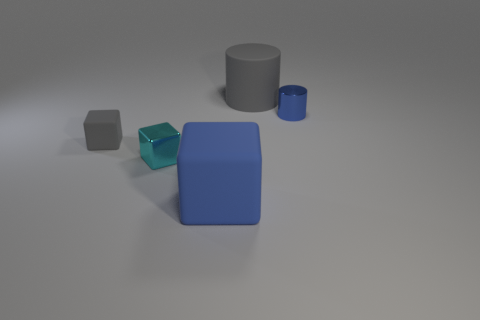What is the size of the gray thing that is the same shape as the big blue thing?
Ensure brevity in your answer.  Small. Is the color of the small matte thing the same as the tiny cylinder?
Provide a succinct answer. No. What is the color of the matte object that is both behind the tiny cyan block and in front of the large gray matte cylinder?
Offer a very short reply. Gray. What number of objects are gray rubber objects that are in front of the big gray object or big rubber objects?
Your answer should be very brief. 3. There is another rubber thing that is the same shape as the small blue object; what is its color?
Give a very brief answer. Gray. Do the big gray rubber thing and the big matte object in front of the gray matte block have the same shape?
Offer a very short reply. No. How many things are either gray objects behind the metallic cylinder or large rubber things that are behind the blue cylinder?
Give a very brief answer. 1. Is the number of big gray cylinders left of the gray matte cylinder less than the number of big gray matte cylinders?
Provide a short and direct response. Yes. Do the large cylinder and the gray object in front of the small blue cylinder have the same material?
Offer a terse response. Yes. What is the material of the cyan object?
Your answer should be very brief. Metal. 